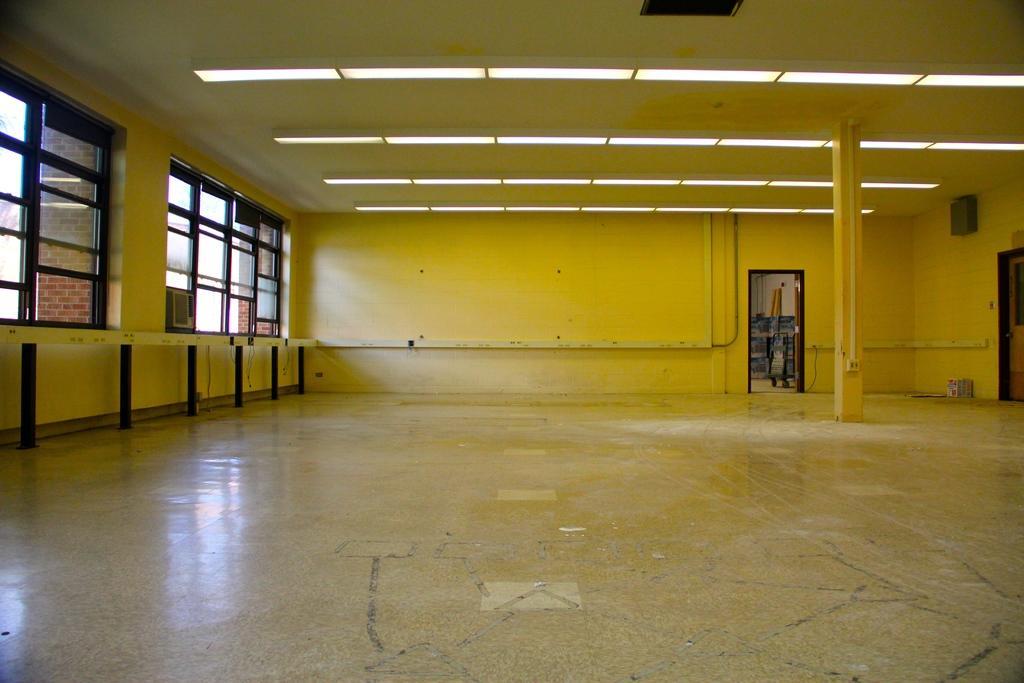Could you give a brief overview of what you see in this image? This picture describes about inside view of a room, in this we can find few lights and a box on the wall. 